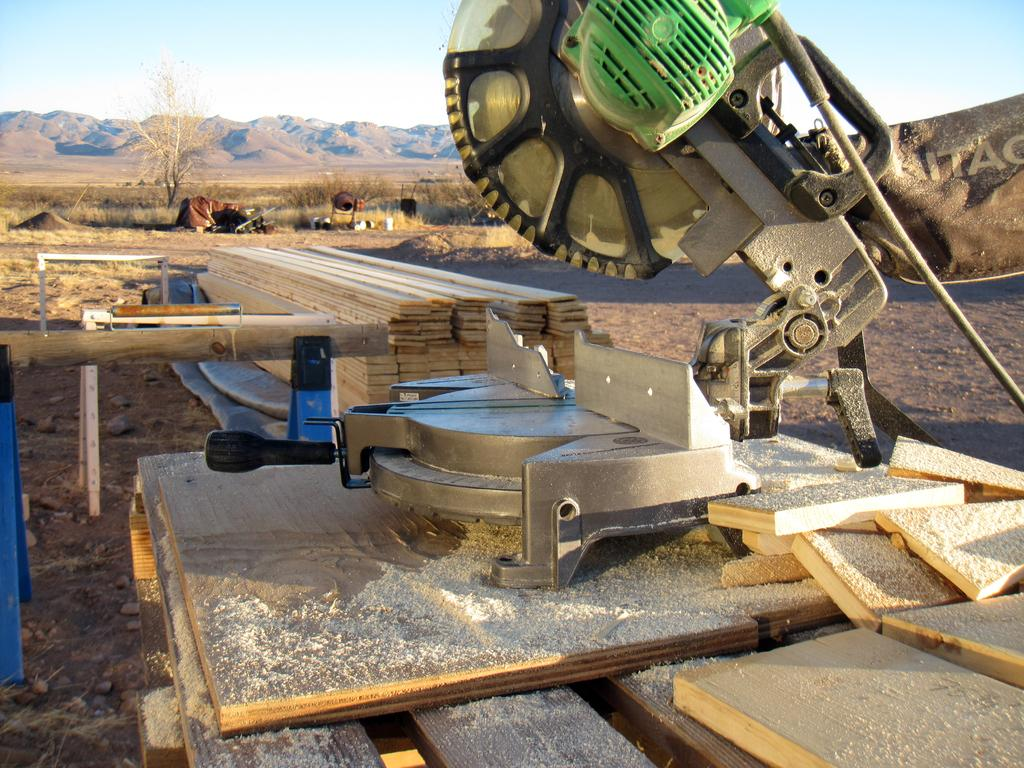What is the main object in the image? There is a machine in the image. What type of natural material can be seen in the image? There is sand visible in the image. What type of material are the objects made of? The objects are made of wood. What type of plant is present in the image? There is a tree in the image. What is the setting of the image? There are other objects on a path in the image. Is there any additional marking on the image? A watermark is visible on the right side of the image. What type of sheet is draped over the machine in the image? There is no sheet present in the image; the machine is not covered. 